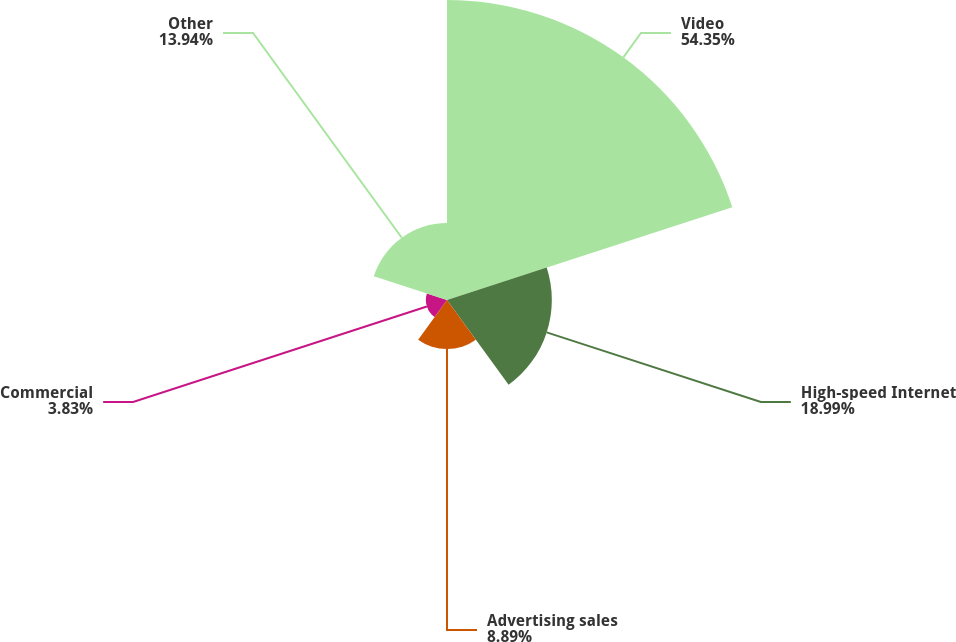<chart> <loc_0><loc_0><loc_500><loc_500><pie_chart><fcel>Video<fcel>High-speed Internet<fcel>Advertising sales<fcel>Commercial<fcel>Other<nl><fcel>54.35%<fcel>18.99%<fcel>8.89%<fcel>3.83%<fcel>13.94%<nl></chart> 